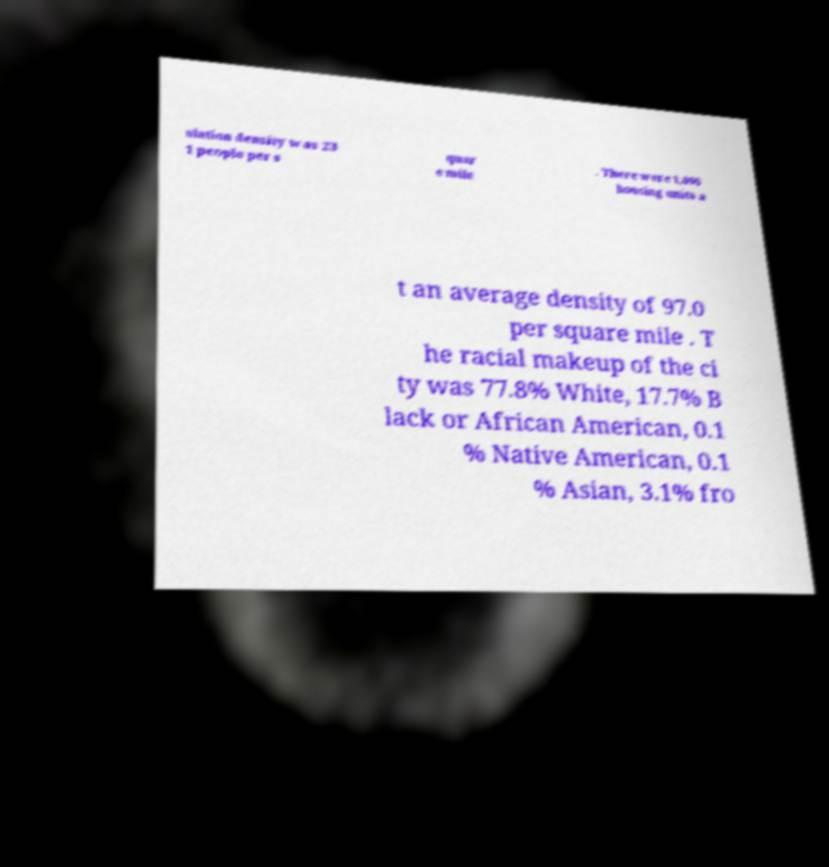There's text embedded in this image that I need extracted. Can you transcribe it verbatim? ulation density was 23 1 people per s quar e mile . There were 1,096 housing units a t an average density of 97.0 per square mile . T he racial makeup of the ci ty was 77.8% White, 17.7% B lack or African American, 0.1 % Native American, 0.1 % Asian, 3.1% fro 